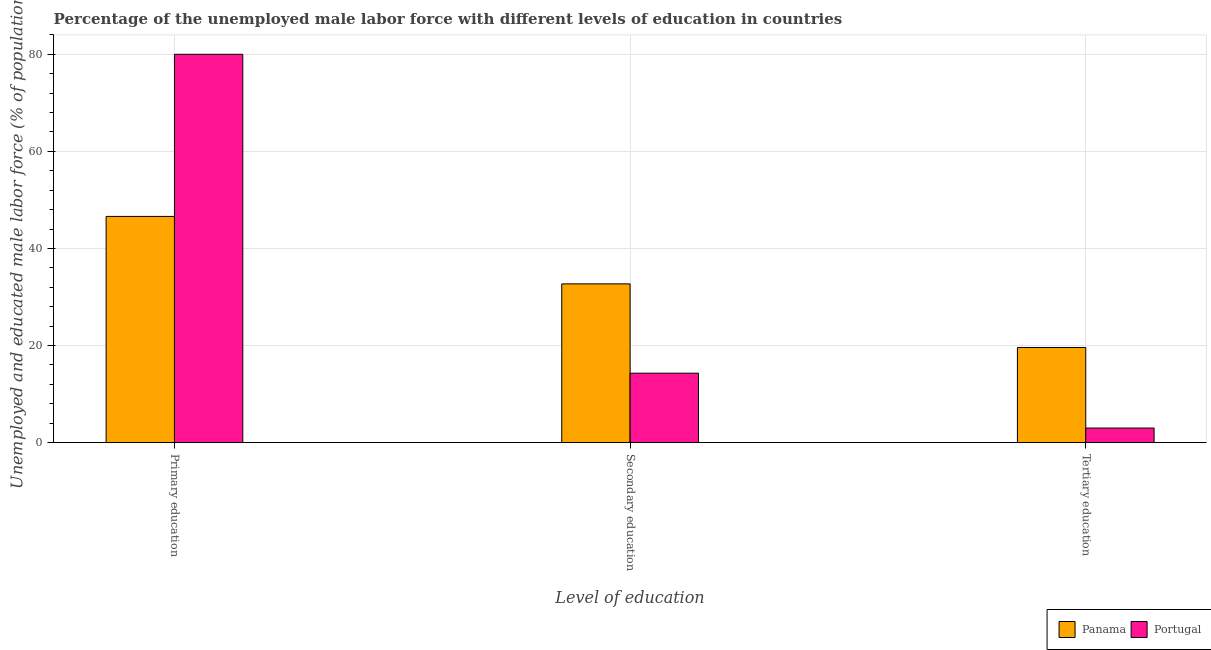How many groups of bars are there?
Give a very brief answer. 3. Are the number of bars per tick equal to the number of legend labels?
Ensure brevity in your answer.  Yes. Are the number of bars on each tick of the X-axis equal?
Give a very brief answer. Yes. How many bars are there on the 1st tick from the left?
Offer a very short reply. 2. What is the label of the 3rd group of bars from the left?
Your answer should be very brief. Tertiary education. What is the percentage of male labor force who received primary education in Panama?
Your answer should be very brief. 46.6. Across all countries, what is the minimum percentage of male labor force who received tertiary education?
Make the answer very short. 3. In which country was the percentage of male labor force who received tertiary education maximum?
Provide a short and direct response. Panama. What is the total percentage of male labor force who received primary education in the graph?
Your response must be concise. 126.6. What is the difference between the percentage of male labor force who received secondary education in Panama and that in Portugal?
Offer a very short reply. 18.4. What is the difference between the percentage of male labor force who received tertiary education in Portugal and the percentage of male labor force who received secondary education in Panama?
Make the answer very short. -29.7. What is the average percentage of male labor force who received primary education per country?
Your response must be concise. 63.3. What is the difference between the percentage of male labor force who received secondary education and percentage of male labor force who received primary education in Panama?
Provide a succinct answer. -13.9. In how many countries, is the percentage of male labor force who received primary education greater than 80 %?
Offer a very short reply. 0. What is the ratio of the percentage of male labor force who received primary education in Panama to that in Portugal?
Keep it short and to the point. 0.58. Is the difference between the percentage of male labor force who received primary education in Portugal and Panama greater than the difference between the percentage of male labor force who received secondary education in Portugal and Panama?
Your answer should be very brief. Yes. What is the difference between the highest and the second highest percentage of male labor force who received tertiary education?
Keep it short and to the point. 16.6. What is the difference between the highest and the lowest percentage of male labor force who received secondary education?
Provide a succinct answer. 18.4. In how many countries, is the percentage of male labor force who received tertiary education greater than the average percentage of male labor force who received tertiary education taken over all countries?
Make the answer very short. 1. What does the 1st bar from the left in Primary education represents?
Your response must be concise. Panama. What does the 1st bar from the right in Primary education represents?
Your answer should be very brief. Portugal. How many bars are there?
Keep it short and to the point. 6. How many countries are there in the graph?
Offer a very short reply. 2. Does the graph contain any zero values?
Offer a terse response. No. What is the title of the graph?
Make the answer very short. Percentage of the unemployed male labor force with different levels of education in countries. Does "Poland" appear as one of the legend labels in the graph?
Provide a succinct answer. No. What is the label or title of the X-axis?
Provide a succinct answer. Level of education. What is the label or title of the Y-axis?
Offer a very short reply. Unemployed and educated male labor force (% of population). What is the Unemployed and educated male labor force (% of population) in Panama in Primary education?
Keep it short and to the point. 46.6. What is the Unemployed and educated male labor force (% of population) in Panama in Secondary education?
Keep it short and to the point. 32.7. What is the Unemployed and educated male labor force (% of population) in Portugal in Secondary education?
Provide a short and direct response. 14.3. What is the Unemployed and educated male labor force (% of population) in Panama in Tertiary education?
Provide a succinct answer. 19.6. What is the Unemployed and educated male labor force (% of population) in Portugal in Tertiary education?
Offer a very short reply. 3. Across all Level of education, what is the maximum Unemployed and educated male labor force (% of population) of Panama?
Keep it short and to the point. 46.6. Across all Level of education, what is the minimum Unemployed and educated male labor force (% of population) in Panama?
Your answer should be compact. 19.6. Across all Level of education, what is the minimum Unemployed and educated male labor force (% of population) of Portugal?
Your answer should be compact. 3. What is the total Unemployed and educated male labor force (% of population) in Panama in the graph?
Offer a very short reply. 98.9. What is the total Unemployed and educated male labor force (% of population) in Portugal in the graph?
Ensure brevity in your answer.  97.3. What is the difference between the Unemployed and educated male labor force (% of population) in Portugal in Primary education and that in Secondary education?
Provide a succinct answer. 65.7. What is the difference between the Unemployed and educated male labor force (% of population) in Portugal in Primary education and that in Tertiary education?
Offer a terse response. 77. What is the difference between the Unemployed and educated male labor force (% of population) of Panama in Primary education and the Unemployed and educated male labor force (% of population) of Portugal in Secondary education?
Make the answer very short. 32.3. What is the difference between the Unemployed and educated male labor force (% of population) of Panama in Primary education and the Unemployed and educated male labor force (% of population) of Portugal in Tertiary education?
Your answer should be compact. 43.6. What is the difference between the Unemployed and educated male labor force (% of population) of Panama in Secondary education and the Unemployed and educated male labor force (% of population) of Portugal in Tertiary education?
Your answer should be compact. 29.7. What is the average Unemployed and educated male labor force (% of population) of Panama per Level of education?
Make the answer very short. 32.97. What is the average Unemployed and educated male labor force (% of population) in Portugal per Level of education?
Provide a succinct answer. 32.43. What is the difference between the Unemployed and educated male labor force (% of population) of Panama and Unemployed and educated male labor force (% of population) of Portugal in Primary education?
Your answer should be compact. -33.4. What is the difference between the Unemployed and educated male labor force (% of population) in Panama and Unemployed and educated male labor force (% of population) in Portugal in Tertiary education?
Provide a short and direct response. 16.6. What is the ratio of the Unemployed and educated male labor force (% of population) in Panama in Primary education to that in Secondary education?
Give a very brief answer. 1.43. What is the ratio of the Unemployed and educated male labor force (% of population) of Portugal in Primary education to that in Secondary education?
Your response must be concise. 5.59. What is the ratio of the Unemployed and educated male labor force (% of population) of Panama in Primary education to that in Tertiary education?
Make the answer very short. 2.38. What is the ratio of the Unemployed and educated male labor force (% of population) in Portugal in Primary education to that in Tertiary education?
Offer a very short reply. 26.67. What is the ratio of the Unemployed and educated male labor force (% of population) in Panama in Secondary education to that in Tertiary education?
Your answer should be compact. 1.67. What is the ratio of the Unemployed and educated male labor force (% of population) in Portugal in Secondary education to that in Tertiary education?
Your response must be concise. 4.77. What is the difference between the highest and the second highest Unemployed and educated male labor force (% of population) of Portugal?
Your response must be concise. 65.7. What is the difference between the highest and the lowest Unemployed and educated male labor force (% of population) in Panama?
Your answer should be very brief. 27. What is the difference between the highest and the lowest Unemployed and educated male labor force (% of population) in Portugal?
Ensure brevity in your answer.  77. 